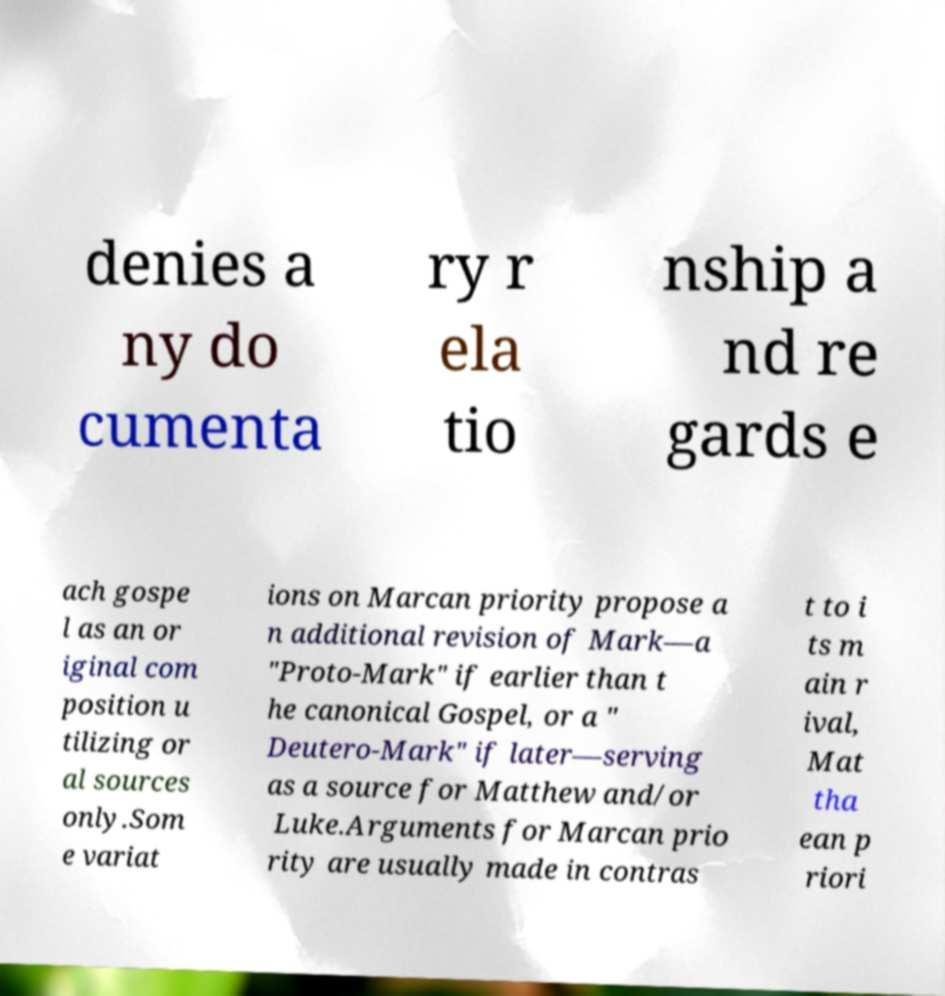For documentation purposes, I need the text within this image transcribed. Could you provide that? denies a ny do cumenta ry r ela tio nship a nd re gards e ach gospe l as an or iginal com position u tilizing or al sources only.Som e variat ions on Marcan priority propose a n additional revision of Mark—a "Proto-Mark" if earlier than t he canonical Gospel, or a " Deutero-Mark" if later—serving as a source for Matthew and/or Luke.Arguments for Marcan prio rity are usually made in contras t to i ts m ain r ival, Mat tha ean p riori 